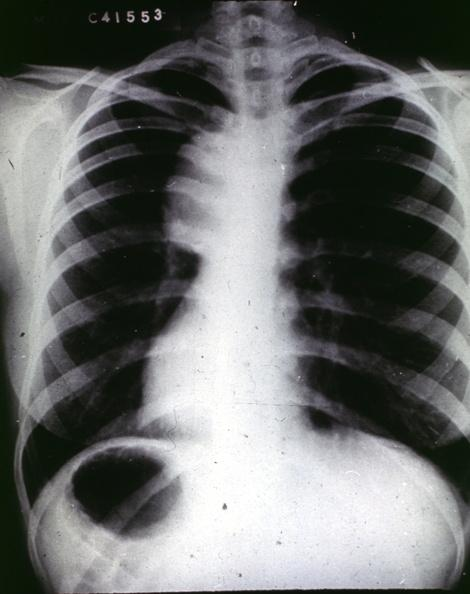s cardiovascular present?
Answer the question using a single word or phrase. Yes 